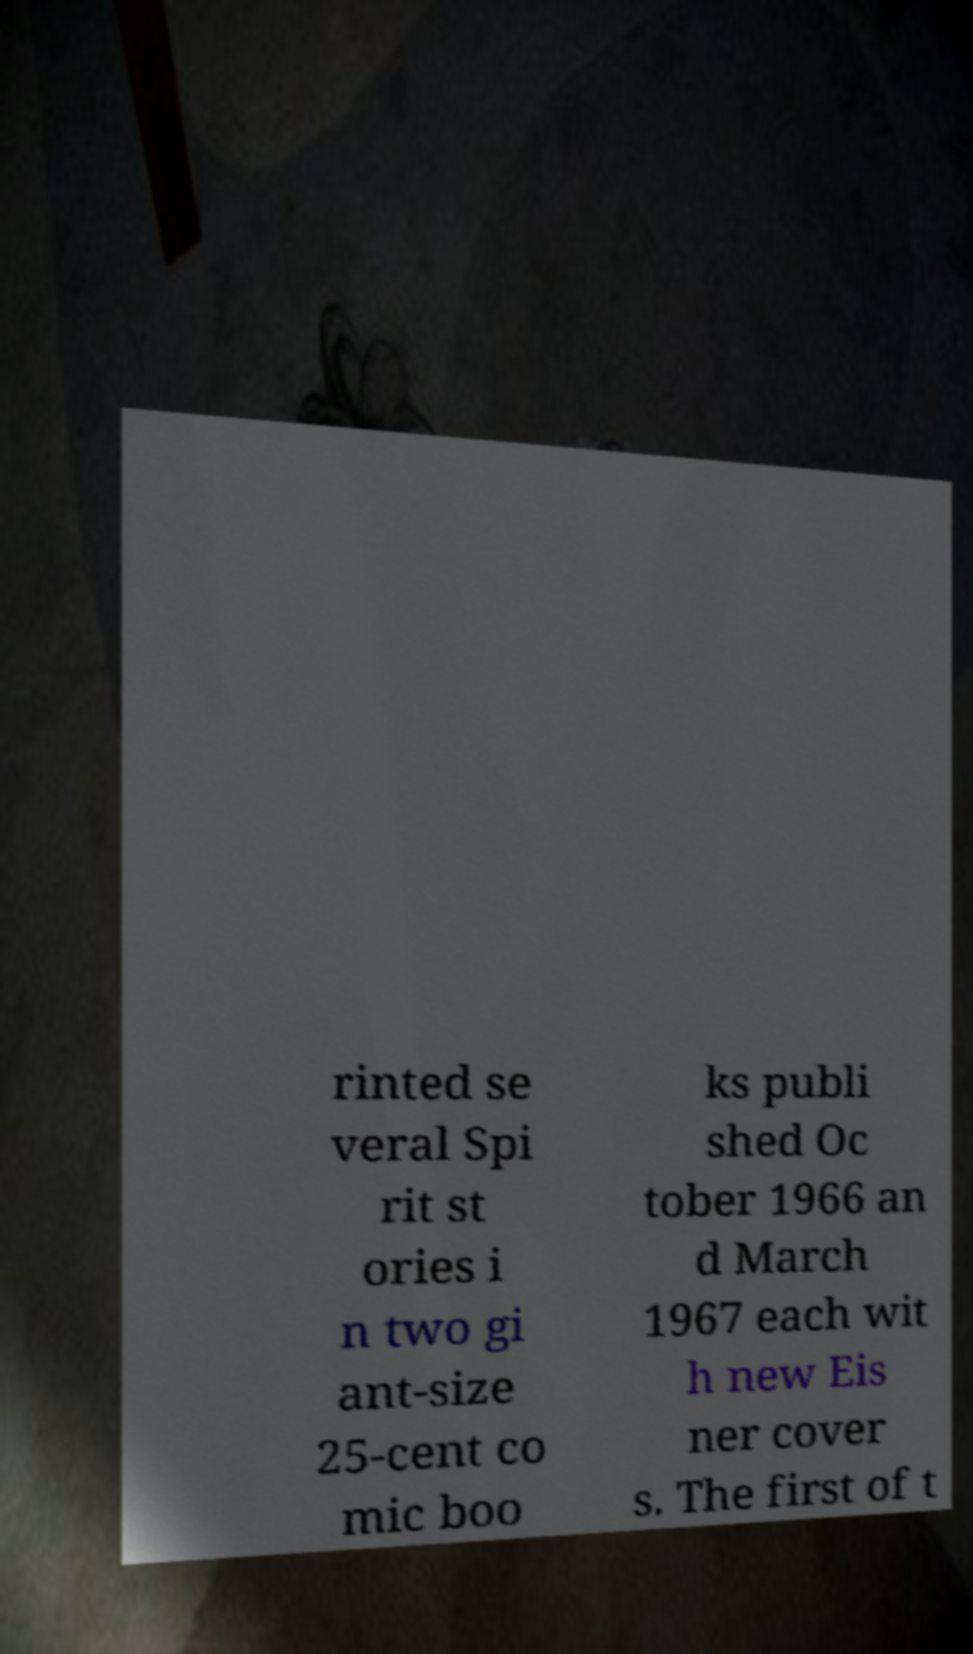Could you assist in decoding the text presented in this image and type it out clearly? rinted se veral Spi rit st ories i n two gi ant-size 25-cent co mic boo ks publi shed Oc tober 1966 an d March 1967 each wit h new Eis ner cover s. The first of t 